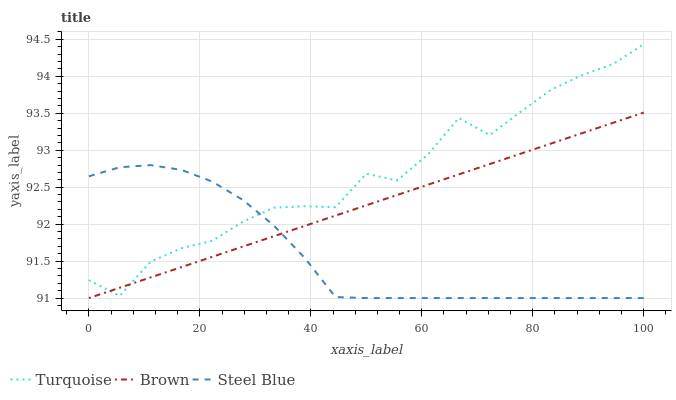Does Steel Blue have the minimum area under the curve?
Answer yes or no. Yes. Does Turquoise have the maximum area under the curve?
Answer yes or no. Yes. Does Turquoise have the minimum area under the curve?
Answer yes or no. No. Does Steel Blue have the maximum area under the curve?
Answer yes or no. No. Is Brown the smoothest?
Answer yes or no. Yes. Is Turquoise the roughest?
Answer yes or no. Yes. Is Steel Blue the smoothest?
Answer yes or no. No. Is Steel Blue the roughest?
Answer yes or no. No. Does Brown have the lowest value?
Answer yes or no. Yes. Does Turquoise have the lowest value?
Answer yes or no. No. Does Turquoise have the highest value?
Answer yes or no. Yes. Does Steel Blue have the highest value?
Answer yes or no. No. Does Turquoise intersect Brown?
Answer yes or no. Yes. Is Turquoise less than Brown?
Answer yes or no. No. Is Turquoise greater than Brown?
Answer yes or no. No. 